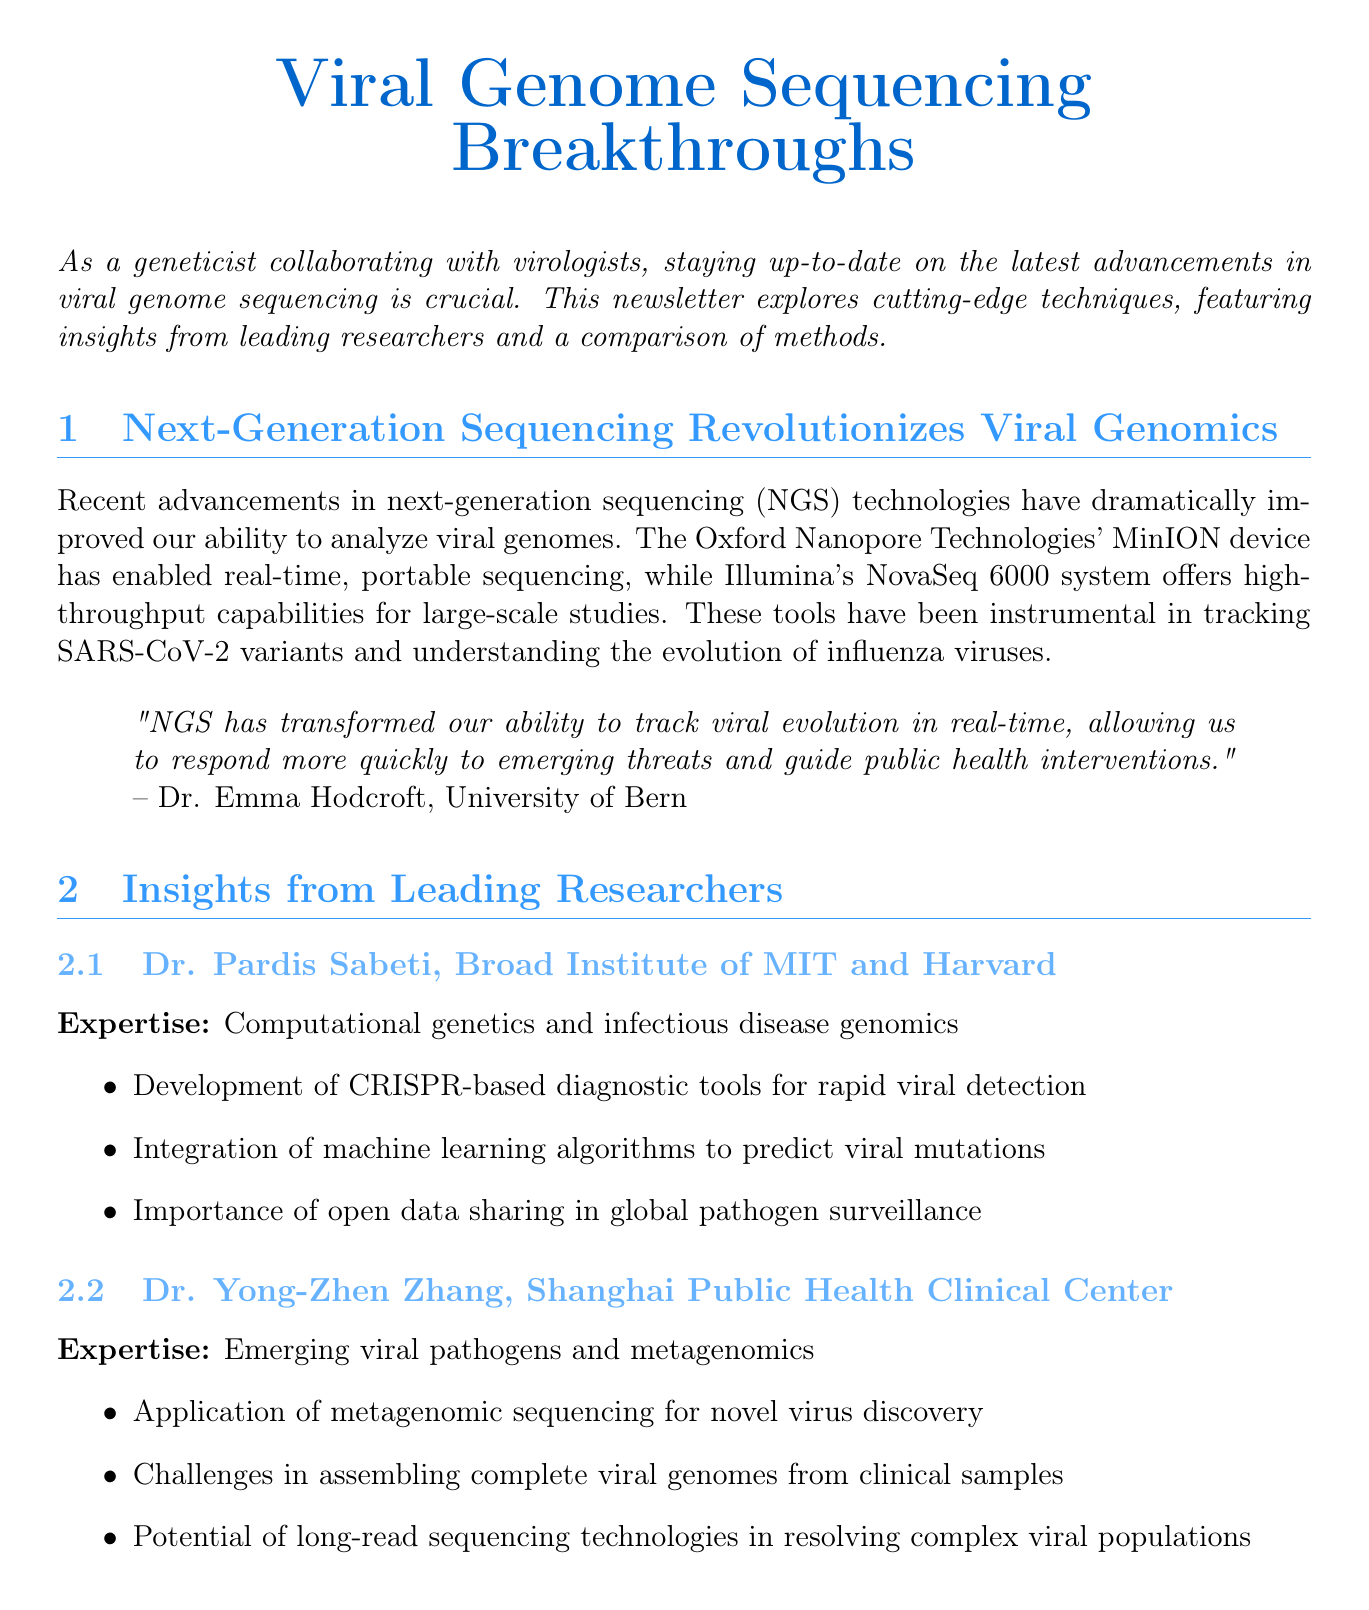What is the title of the newsletter? The title is prominently featured at the top of the document.
Answer: Viral Genome Sequencing Breakthroughs Who is the expert quoted in the main article? The document provides a specific quote from an expert, including their name and affiliation.
Answer: Dr. Emma Hodcroft Which sequencing method is associated with real-time data analysis? The document describes different methods, highlighting the specific advantages associated with each.
Answer: Oxford Nanopore Long-Read Sequencing What is one of Dr. Yong-Zhen Zhang's key insights? The document lists key insights from two researchers, under each expert's section.
Answer: Application of metagenomic sequencing for novel virus discovery What is one emerging trend in viral genomics mentioned? The document lists trends indicating the future directions in the field of viral genomics.
Answer: Integration of artificial intelligence for improved variant calling and genome assembly What is one disadvantage of Illumina Short-Read Sequencing? The comparison chart lists specific advantages and disadvantages for each sequencing method.
Answer: Difficulty in resolving repetitive regions How many researchers are interviewed in the newsletter? The document lists the number of researcher interviews featured in the article.
Answer: Two What is the affiliation of Dr. Pardis Sabeti? The document explicitly states the affiliations of the researchers interviewed.
Answer: Broad Institute of MIT and Harvard 